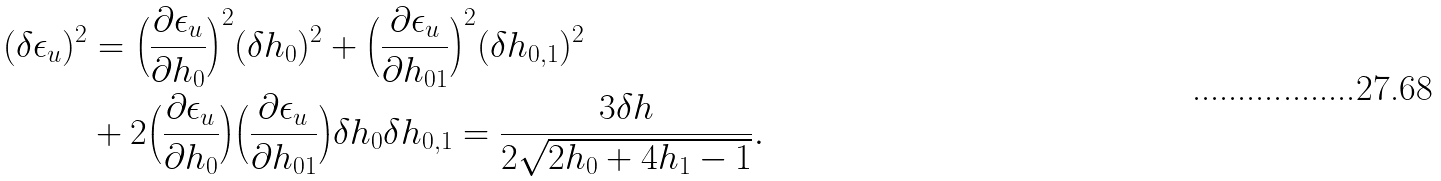Convert formula to latex. <formula><loc_0><loc_0><loc_500><loc_500>( \delta \epsilon _ { u } ) ^ { 2 } & = \Big { ( } \frac { \partial \epsilon _ { u } } { \partial h _ { 0 } } \Big { ) } ^ { 2 } ( \delta h _ { 0 } ) ^ { 2 } + \Big { ( } \frac { \partial \epsilon _ { u } } { \partial h _ { 0 1 } } \Big { ) } ^ { 2 } ( \delta h _ { 0 , 1 } ) ^ { 2 } \\ & + 2 \Big { ( } \frac { \partial \epsilon _ { u } } { \partial h _ { 0 } } \Big { ) } \Big { ( } \frac { \partial \epsilon _ { u } } { \partial h _ { 0 1 } } \Big { ) } \delta h _ { 0 } \delta h _ { 0 , 1 } = \frac { 3 \delta h } { 2 \sqrt { 2 h _ { 0 } + 4 h _ { 1 } - 1 } } .</formula> 